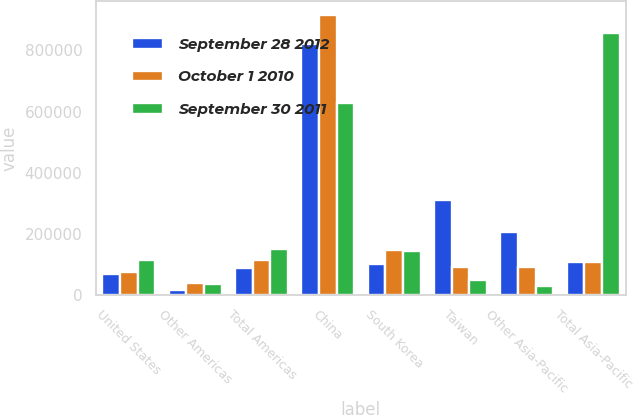<chart> <loc_0><loc_0><loc_500><loc_500><stacked_bar_chart><ecel><fcel>United States<fcel>Other Americas<fcel>Total Americas<fcel>China<fcel>South Korea<fcel>Taiwan<fcel>Other Asia-Pacific<fcel>Total Asia-Pacific<nl><fcel>September 28 2012<fcel>70259<fcel>18373<fcel>88632<fcel>820134<fcel>103213<fcel>311728<fcel>207337<fcel>109412<nl><fcel>October 1 2010<fcel>76764<fcel>38863<fcel>115627<fcel>914678<fcel>148370<fcel>93753<fcel>91521<fcel>109412<nl><fcel>September 30 2011<fcel>115610<fcel>36724<fcel>152334<fcel>628858<fcel>144758<fcel>51353<fcel>30922<fcel>855891<nl></chart> 